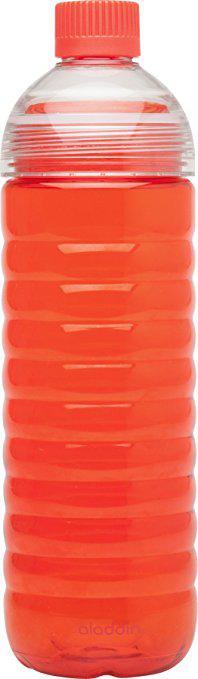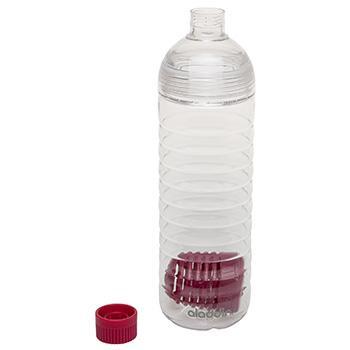The first image is the image on the left, the second image is the image on the right. Evaluate the accuracy of this statement regarding the images: "An image shows a clear water bottle containing a solid-colored perforated cylindrical item inside at the bottom.". Is it true? Answer yes or no. Yes. 